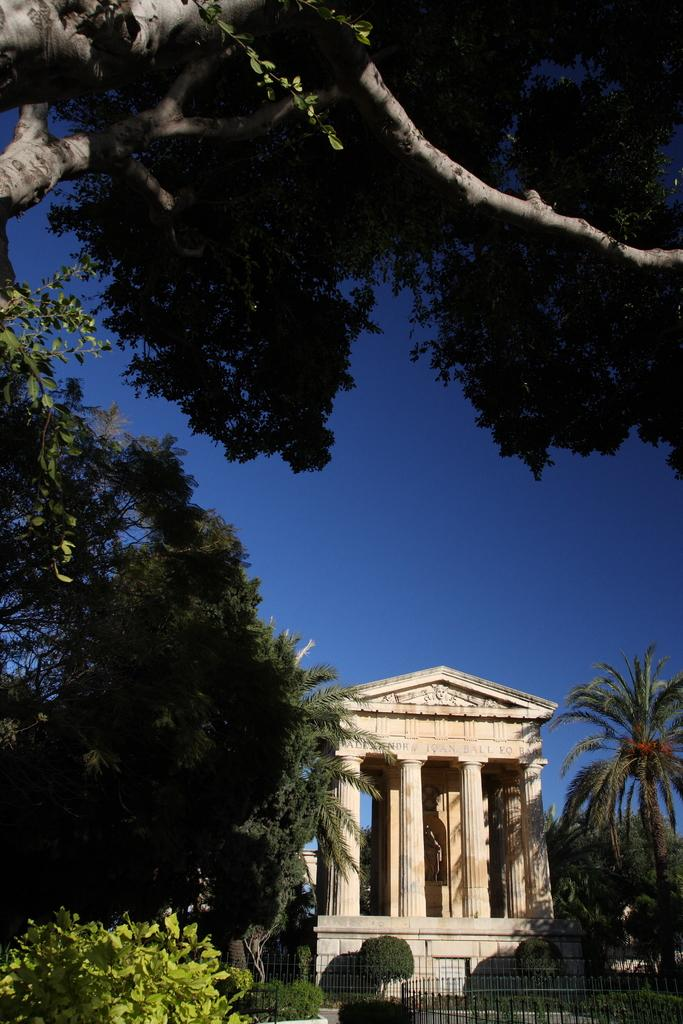What type of structure is depicted in the image? There is a building with pillars in the image. What architectural feature can be seen at the bottom of the image? There are iron grilles at the bottom of the image. What type of vegetation is visible in the image? Trees and bushes are visible in the image. What can be seen in the background of the image? The sky is visible in the background of the image. How many deer are visible in the image? There are no deer present in the image. What type of work is being done on the building in the image? There is no indication of any work being done on the building in the image. 